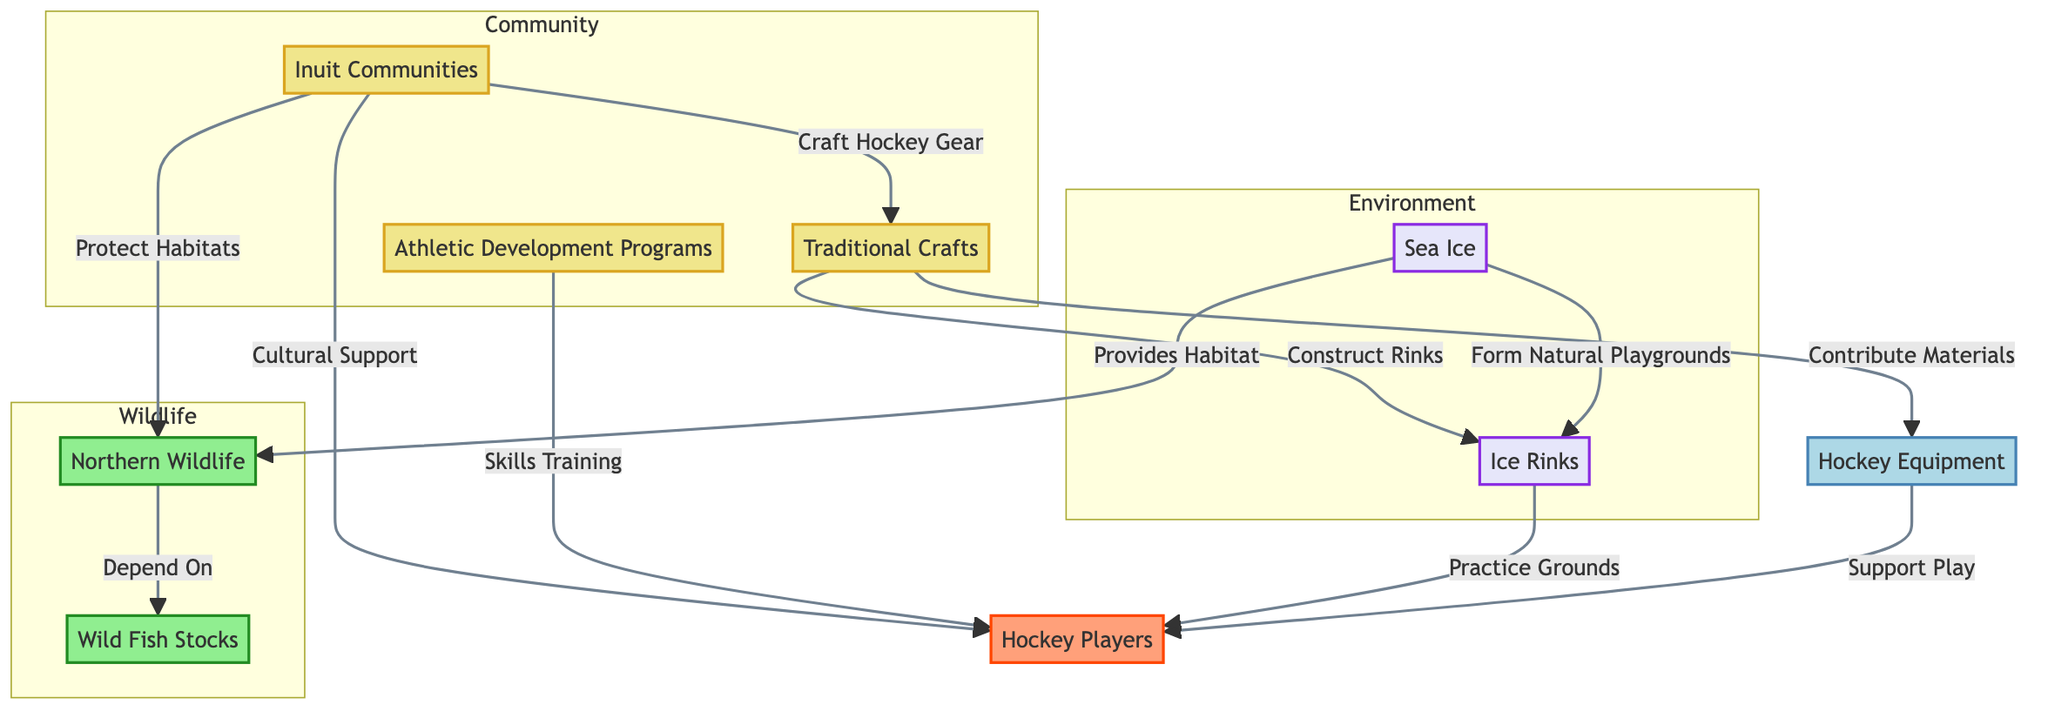What is the purpose of Traditional Crafts in the diagram? Traditional Crafts contribute materials to Hockey Equipment and are involved in constructing rinks, which support hockey culture in Inuit communities.
Answer: Contribute materials How many distinct community nodes are present in the diagram? There are three community nodes: Inuit Communities, Traditional Crafts, and Athletic Development Programs.
Answer: 3 What wildlife does Northern Wildlife depend on? Northern Wildlife depends on Wild Fish Stocks, illustrating the dependency within the ecosystem that's critical for supporting hockey culture.
Answer: Wild Fish Stocks What types of support do Inuit Communities provide to Hockey Players? Inuit Communities provide cultural support and help in skills training through Athletic Development Programs, integrating community efforts into player development.
Answer: Cultural support and skills training How does Sea Ice contribute to the ecosystem depicted in the diagram? Sea Ice serves as both a habitat for Northern Wildlife and forms natural playgrounds for ice rinks, framing the environmental aspect of hockey culture.
Answer: Habitat and playgrounds What do Athletic Development Programs offer to Hockey Players? Athletic Development Programs focus on skills training, which is essential for the development of hockey players within this cultural context.
Answer: Skills training What is the relationship between Ice Rinks and Hockey Players? Ice Rinks serve as practice grounds for Hockey Players, providing the necessary facilities for them to develop their skills.
Answer: Practice grounds How many links are there from Inuit Communities to other nodes? Inuit Communities link to Traditional Crafts, Northern Wildlife, and Hockey Players, resulting in three connections overall.
Answer: 3 Which two environments are highlighted in the diagram? The environments highlighted in the diagram are Sea Ice and Ice Rinks, both playing significant roles in supporting hockey culture.
Answer: Sea Ice and Ice Rinks 